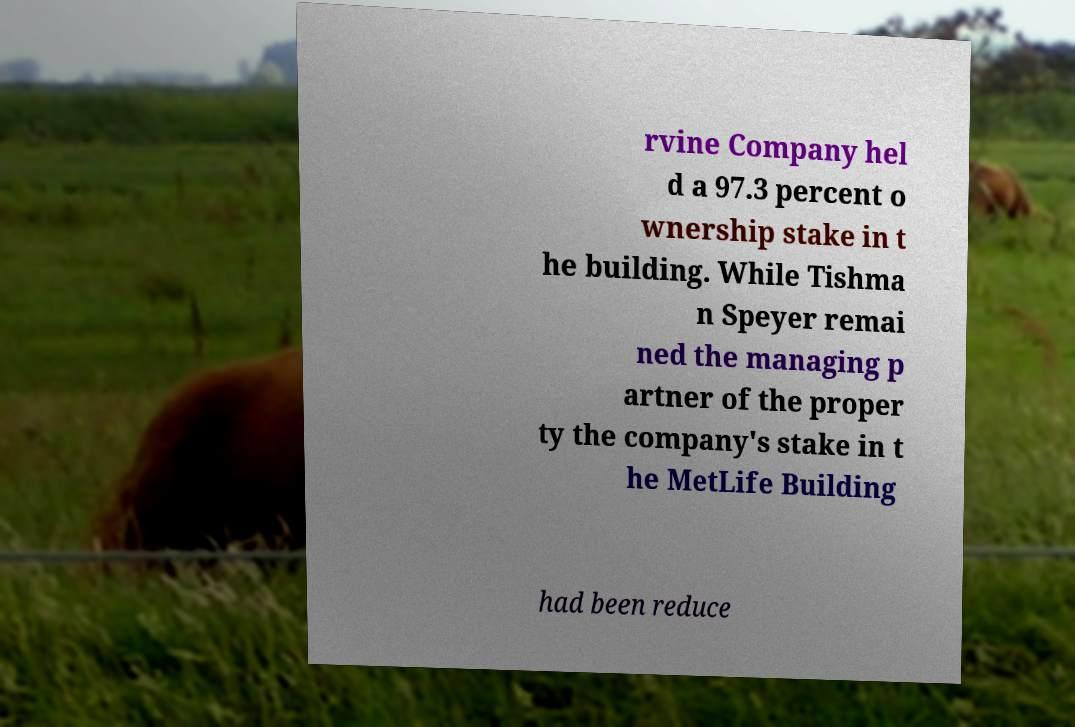Could you extract and type out the text from this image? rvine Company hel d a 97.3 percent o wnership stake in t he building. While Tishma n Speyer remai ned the managing p artner of the proper ty the company's stake in t he MetLife Building had been reduce 